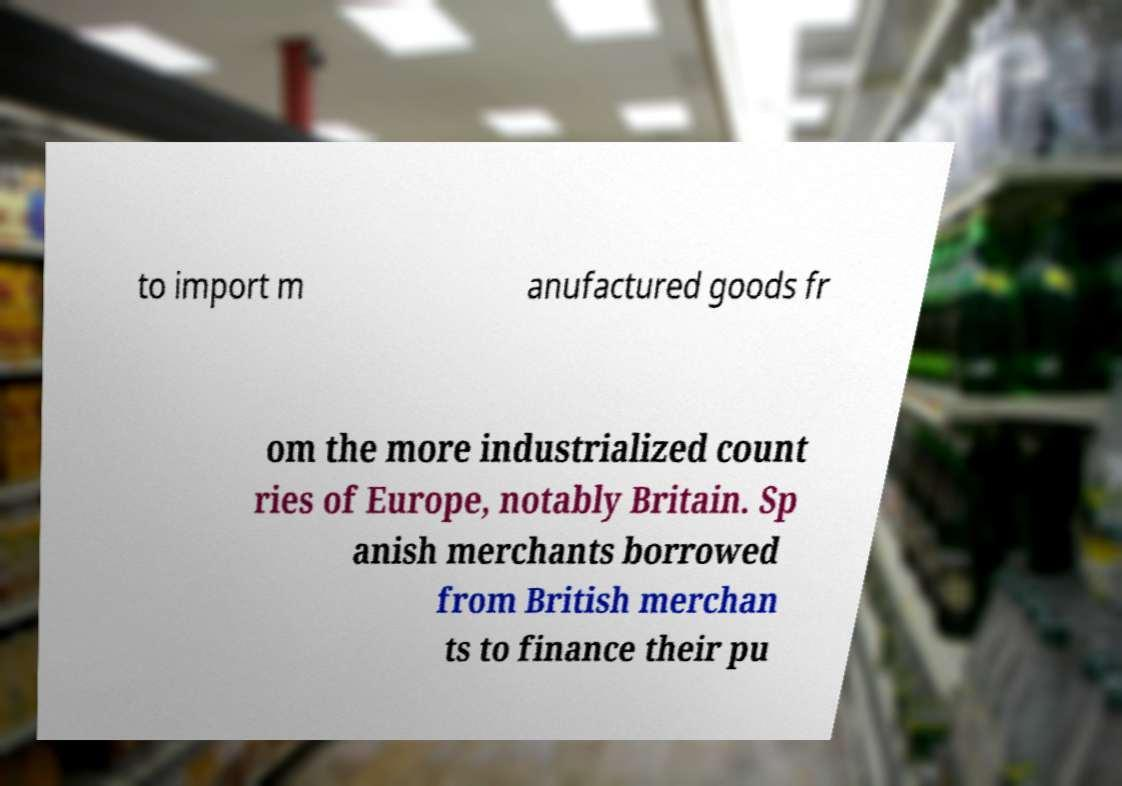Please identify and transcribe the text found in this image. to import m anufactured goods fr om the more industrialized count ries of Europe, notably Britain. Sp anish merchants borrowed from British merchan ts to finance their pu 